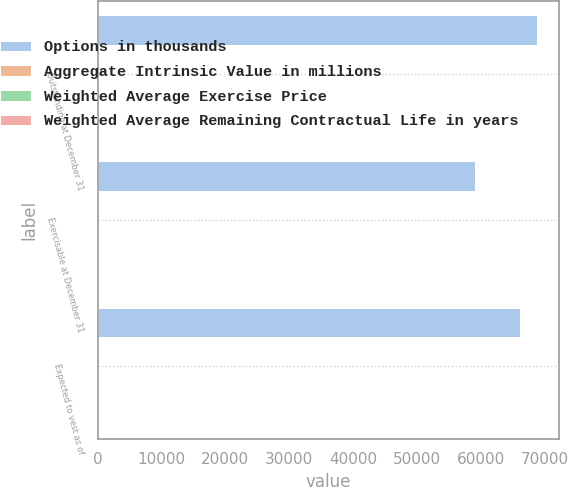Convert chart. <chart><loc_0><loc_0><loc_500><loc_500><stacked_bar_chart><ecel><fcel>Outstanding at December 31<fcel>Exercisable at December 31<fcel>Expected to vest as of<nl><fcel>Options in thousands<fcel>68741<fcel>59045<fcel>66151<nl><fcel>Aggregate Intrinsic Value in millions<fcel>17<fcel>16<fcel>17<nl><fcel>Weighted Average Exercise Price<fcel>4<fcel>3<fcel>4<nl><fcel>Weighted Average Remaining Contractual Life in years<fcel>46<fcel>46<fcel>46<nl></chart> 